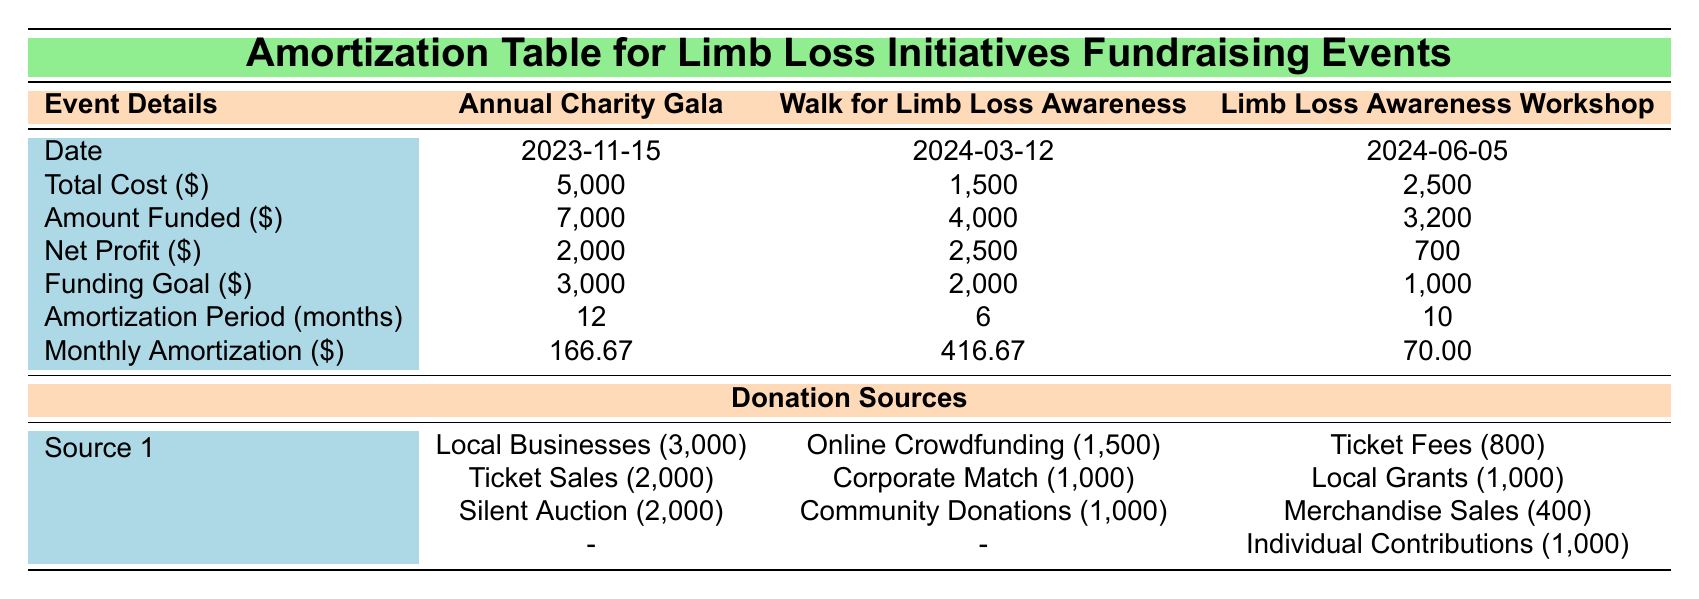What is the date of the Annual Charity Gala? The table specifies the date for each event. For the Annual Charity Gala, the date is listed as 2023-11-15.
Answer: 2023-11-15 How much was the total cost for the Walk for Limb Loss Awareness? The total cost for the Walk for Limb Loss Awareness is directly provided in the table under the "Total Cost" column, which shows 1,500.
Answer: 1,500 Which event had the highest net profit? The net profits for each event are listed: 2,000 for the Annual Charity Gala, 2,500 for the Walk for Limb Loss Awareness, and 700 for the Limb Loss Awareness Workshop. The highest value is 2,500.
Answer: Walk for Limb Loss Awareness What is the sum of the funding goals for all events? The funding goals for each event are 3,000, 2,000, and 1,000. Adding these together: 3,000 + 2,000 + 1,000 = 6,000.
Answer: 6,000 Is the amount funded for the Limb Loss Awareness Workshop greater than its total cost? The amount funded (3,200) is compared to the total cost (2,500). Since 3,200 is greater than 2,500, the statement is true.
Answer: Yes Which event has the largest monthly amortization and what is its value? The monthly amortization values listed are 166.67 for the Annual Charity Gala, 416.67 for the Walk for Limb Loss Awareness, and 70.00 for the Limb Loss Awareness Workshop. The largest value is 416.67.
Answer: 416.67 What percentage of the total cost is covered by the amount funded for the Annual Charity Gala? The total cost is 5,000 and the amount funded is 7,000. To find the percentage covered: (7,000 / 5,000) * 100 = 140%.
Answer: 140% If the funding goal for the Limb Loss Awareness Workshop was met, what would be the total excess amount funded? The funding goal is 1,000 and the amount funded is 3,200. The excess amount would be 3,200 - 1,000 = 2,200.
Answer: 2,200 What was the contribution from Ticket Sales for the Annual Charity Gala? The contribution from Ticket Sales is clearly listed as 2,000 within the donation sources section for the Annual Charity Gala.
Answer: 2,000 